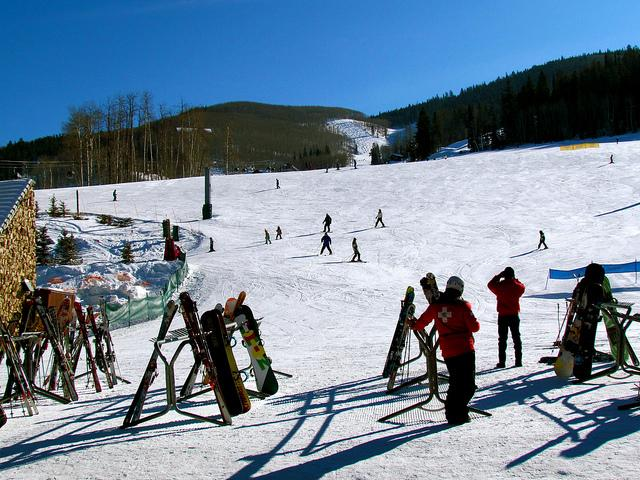The instrument in the picture is used to play for? skiing 